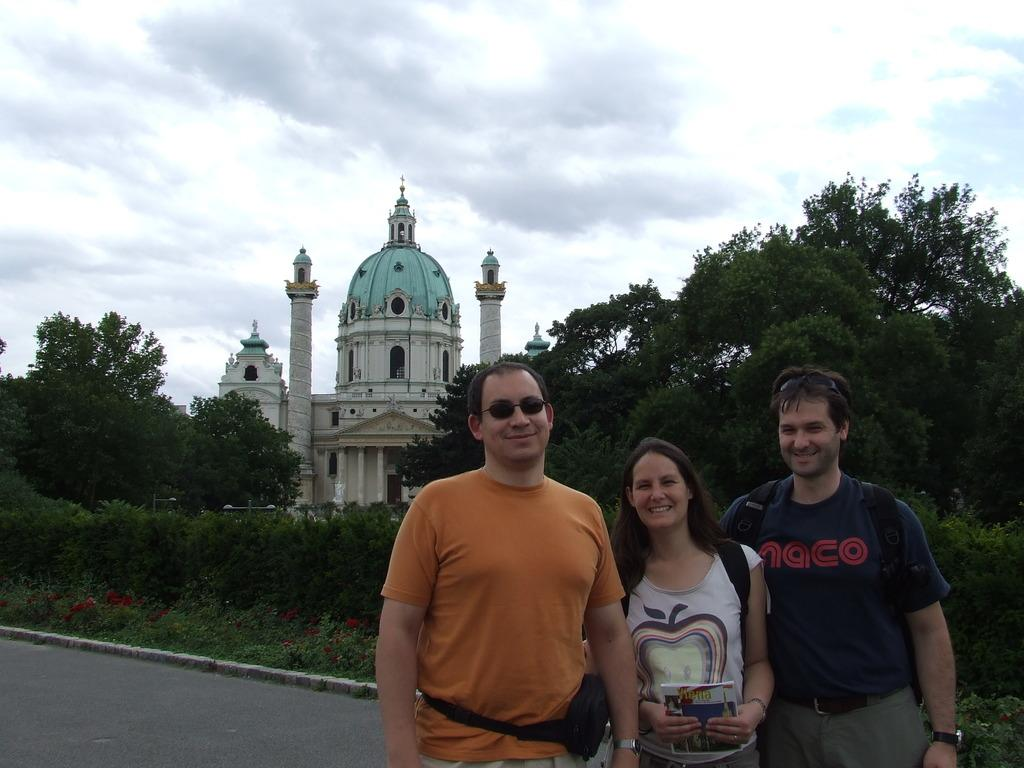How many people are present in the image? There are three persons standing in the image. What can be seen in the background of the image? There are plants, a road, trees, a building, and the sky visible in the background of the image. What type of scarf is the person on the left wearing in the image? There is no scarf visible on any of the persons in the image. Can you tell me which store the persons are standing in front of in the image? There is no store present in the image; it only shows the persons and the background elements. 